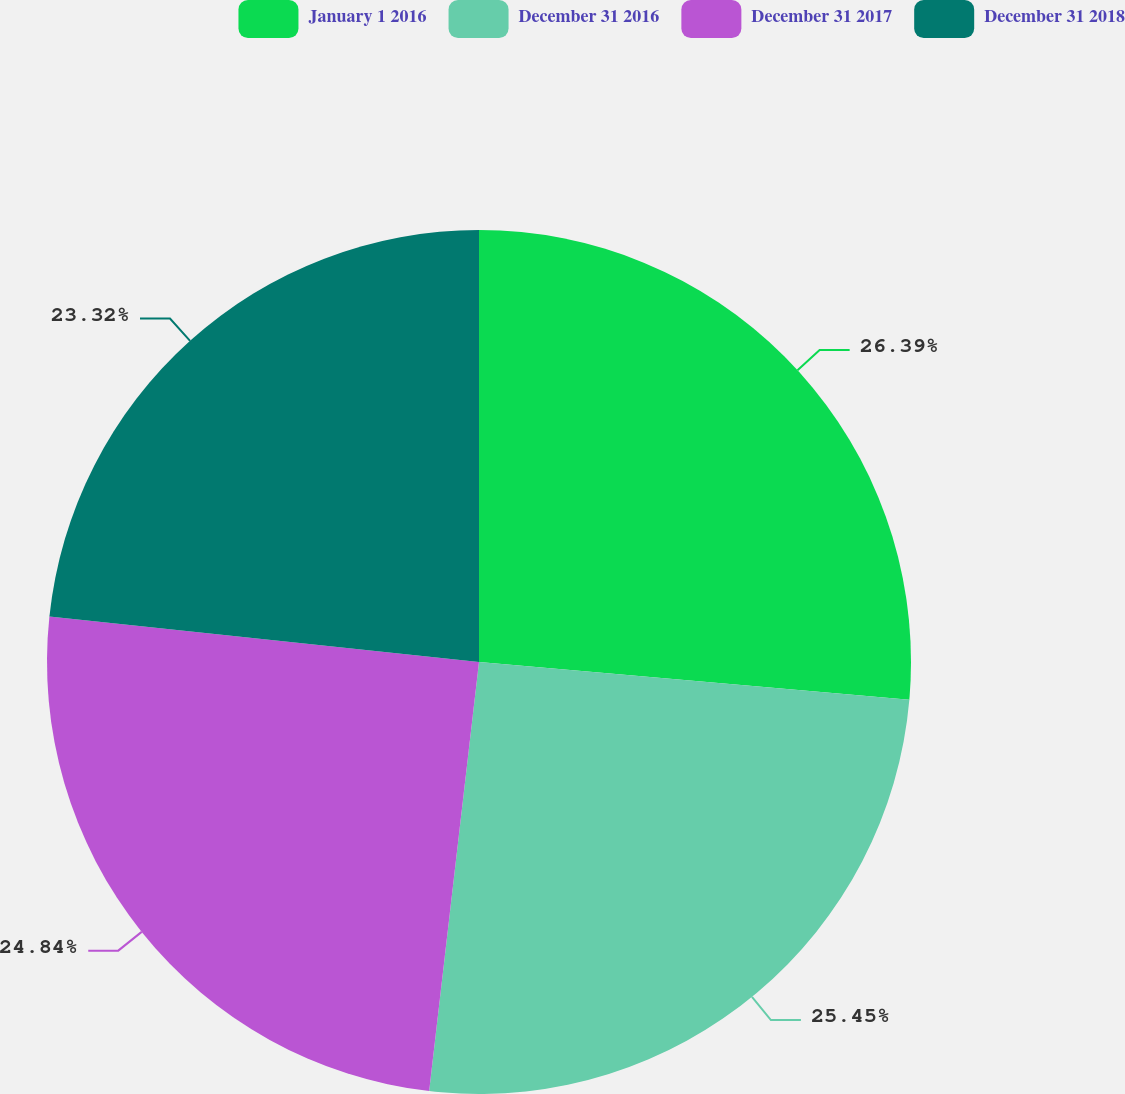<chart> <loc_0><loc_0><loc_500><loc_500><pie_chart><fcel>January 1 2016<fcel>December 31 2016<fcel>December 31 2017<fcel>December 31 2018<nl><fcel>26.39%<fcel>25.45%<fcel>24.84%<fcel>23.32%<nl></chart> 